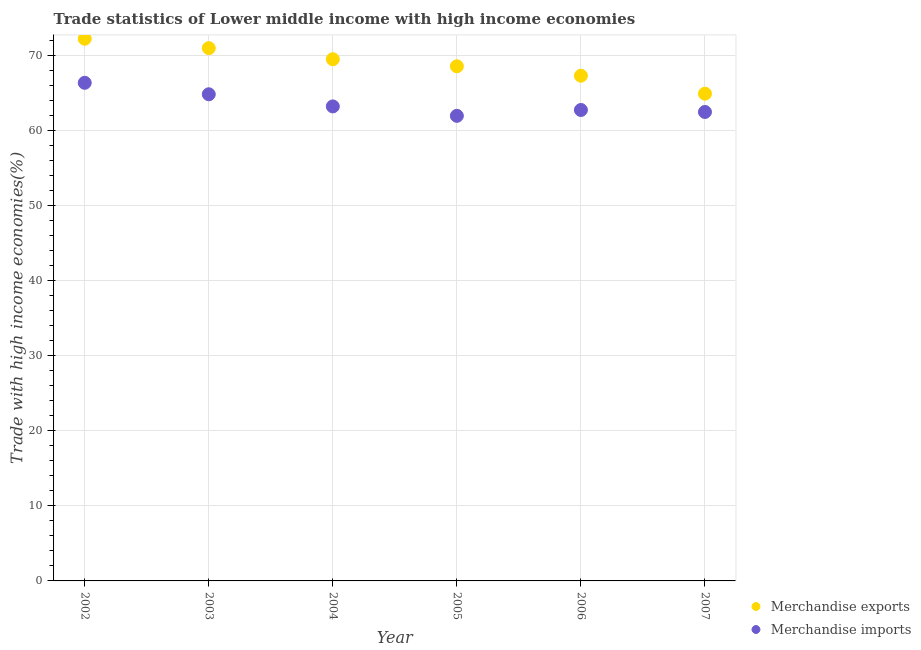Is the number of dotlines equal to the number of legend labels?
Offer a very short reply. Yes. What is the merchandise exports in 2005?
Ensure brevity in your answer.  68.62. Across all years, what is the maximum merchandise imports?
Make the answer very short. 66.42. Across all years, what is the minimum merchandise imports?
Keep it short and to the point. 62.02. What is the total merchandise imports in the graph?
Provide a succinct answer. 381.92. What is the difference between the merchandise exports in 2002 and that in 2003?
Your answer should be compact. 1.26. What is the difference between the merchandise exports in 2007 and the merchandise imports in 2006?
Provide a short and direct response. 2.17. What is the average merchandise exports per year?
Your answer should be compact. 68.98. In the year 2006, what is the difference between the merchandise imports and merchandise exports?
Offer a very short reply. -4.57. In how many years, is the merchandise imports greater than 30 %?
Give a very brief answer. 6. What is the ratio of the merchandise imports in 2004 to that in 2007?
Your answer should be very brief. 1.01. What is the difference between the highest and the second highest merchandise imports?
Your answer should be compact. 1.53. What is the difference between the highest and the lowest merchandise imports?
Offer a terse response. 4.4. Is the merchandise imports strictly greater than the merchandise exports over the years?
Keep it short and to the point. No. How many years are there in the graph?
Your answer should be compact. 6. What is the title of the graph?
Provide a short and direct response. Trade statistics of Lower middle income with high income economies. Does "Not attending school" appear as one of the legend labels in the graph?
Keep it short and to the point. No. What is the label or title of the X-axis?
Offer a terse response. Year. What is the label or title of the Y-axis?
Provide a succinct answer. Trade with high income economies(%). What is the Trade with high income economies(%) in Merchandise exports in 2002?
Provide a short and direct response. 72.3. What is the Trade with high income economies(%) of Merchandise imports in 2002?
Your answer should be very brief. 66.42. What is the Trade with high income economies(%) in Merchandise exports in 2003?
Provide a short and direct response. 71.04. What is the Trade with high income economies(%) in Merchandise imports in 2003?
Offer a very short reply. 64.89. What is the Trade with high income economies(%) in Merchandise exports in 2004?
Offer a very short reply. 69.56. What is the Trade with high income economies(%) of Merchandise imports in 2004?
Your answer should be compact. 63.27. What is the Trade with high income economies(%) of Merchandise exports in 2005?
Provide a succinct answer. 68.62. What is the Trade with high income economies(%) in Merchandise imports in 2005?
Your answer should be very brief. 62.02. What is the Trade with high income economies(%) of Merchandise exports in 2006?
Provide a short and direct response. 67.37. What is the Trade with high income economies(%) in Merchandise imports in 2006?
Your answer should be compact. 62.8. What is the Trade with high income economies(%) of Merchandise exports in 2007?
Provide a short and direct response. 64.97. What is the Trade with high income economies(%) of Merchandise imports in 2007?
Provide a succinct answer. 62.53. Across all years, what is the maximum Trade with high income economies(%) of Merchandise exports?
Make the answer very short. 72.3. Across all years, what is the maximum Trade with high income economies(%) of Merchandise imports?
Keep it short and to the point. 66.42. Across all years, what is the minimum Trade with high income economies(%) in Merchandise exports?
Your response must be concise. 64.97. Across all years, what is the minimum Trade with high income economies(%) of Merchandise imports?
Provide a succinct answer. 62.02. What is the total Trade with high income economies(%) of Merchandise exports in the graph?
Provide a succinct answer. 413.86. What is the total Trade with high income economies(%) of Merchandise imports in the graph?
Your answer should be compact. 381.92. What is the difference between the Trade with high income economies(%) in Merchandise exports in 2002 and that in 2003?
Ensure brevity in your answer.  1.26. What is the difference between the Trade with high income economies(%) of Merchandise imports in 2002 and that in 2003?
Give a very brief answer. 1.53. What is the difference between the Trade with high income economies(%) of Merchandise exports in 2002 and that in 2004?
Provide a succinct answer. 2.73. What is the difference between the Trade with high income economies(%) in Merchandise imports in 2002 and that in 2004?
Keep it short and to the point. 3.15. What is the difference between the Trade with high income economies(%) in Merchandise exports in 2002 and that in 2005?
Offer a very short reply. 3.67. What is the difference between the Trade with high income economies(%) in Merchandise imports in 2002 and that in 2005?
Your response must be concise. 4.4. What is the difference between the Trade with high income economies(%) of Merchandise exports in 2002 and that in 2006?
Offer a very short reply. 4.93. What is the difference between the Trade with high income economies(%) of Merchandise imports in 2002 and that in 2006?
Provide a short and direct response. 3.62. What is the difference between the Trade with high income economies(%) in Merchandise exports in 2002 and that in 2007?
Offer a very short reply. 7.33. What is the difference between the Trade with high income economies(%) in Merchandise imports in 2002 and that in 2007?
Give a very brief answer. 3.89. What is the difference between the Trade with high income economies(%) in Merchandise exports in 2003 and that in 2004?
Ensure brevity in your answer.  1.48. What is the difference between the Trade with high income economies(%) in Merchandise imports in 2003 and that in 2004?
Offer a terse response. 1.62. What is the difference between the Trade with high income economies(%) of Merchandise exports in 2003 and that in 2005?
Provide a short and direct response. 2.42. What is the difference between the Trade with high income economies(%) in Merchandise imports in 2003 and that in 2005?
Ensure brevity in your answer.  2.87. What is the difference between the Trade with high income economies(%) in Merchandise exports in 2003 and that in 2006?
Your answer should be compact. 3.68. What is the difference between the Trade with high income economies(%) of Merchandise imports in 2003 and that in 2006?
Your answer should be very brief. 2.09. What is the difference between the Trade with high income economies(%) of Merchandise exports in 2003 and that in 2007?
Offer a very short reply. 6.07. What is the difference between the Trade with high income economies(%) in Merchandise imports in 2003 and that in 2007?
Give a very brief answer. 2.36. What is the difference between the Trade with high income economies(%) of Merchandise exports in 2004 and that in 2005?
Provide a short and direct response. 0.94. What is the difference between the Trade with high income economies(%) of Merchandise imports in 2004 and that in 2005?
Give a very brief answer. 1.26. What is the difference between the Trade with high income economies(%) in Merchandise exports in 2004 and that in 2006?
Make the answer very short. 2.2. What is the difference between the Trade with high income economies(%) in Merchandise imports in 2004 and that in 2006?
Give a very brief answer. 0.48. What is the difference between the Trade with high income economies(%) of Merchandise exports in 2004 and that in 2007?
Provide a short and direct response. 4.59. What is the difference between the Trade with high income economies(%) in Merchandise imports in 2004 and that in 2007?
Offer a terse response. 0.74. What is the difference between the Trade with high income economies(%) in Merchandise exports in 2005 and that in 2006?
Ensure brevity in your answer.  1.26. What is the difference between the Trade with high income economies(%) in Merchandise imports in 2005 and that in 2006?
Ensure brevity in your answer.  -0.78. What is the difference between the Trade with high income economies(%) of Merchandise exports in 2005 and that in 2007?
Your answer should be compact. 3.65. What is the difference between the Trade with high income economies(%) of Merchandise imports in 2005 and that in 2007?
Your answer should be compact. -0.51. What is the difference between the Trade with high income economies(%) in Merchandise exports in 2006 and that in 2007?
Give a very brief answer. 2.4. What is the difference between the Trade with high income economies(%) of Merchandise imports in 2006 and that in 2007?
Keep it short and to the point. 0.27. What is the difference between the Trade with high income economies(%) in Merchandise exports in 2002 and the Trade with high income economies(%) in Merchandise imports in 2003?
Provide a short and direct response. 7.41. What is the difference between the Trade with high income economies(%) of Merchandise exports in 2002 and the Trade with high income economies(%) of Merchandise imports in 2004?
Offer a very short reply. 9.03. What is the difference between the Trade with high income economies(%) in Merchandise exports in 2002 and the Trade with high income economies(%) in Merchandise imports in 2005?
Make the answer very short. 10.28. What is the difference between the Trade with high income economies(%) in Merchandise exports in 2002 and the Trade with high income economies(%) in Merchandise imports in 2006?
Ensure brevity in your answer.  9.5. What is the difference between the Trade with high income economies(%) in Merchandise exports in 2002 and the Trade with high income economies(%) in Merchandise imports in 2007?
Provide a succinct answer. 9.77. What is the difference between the Trade with high income economies(%) in Merchandise exports in 2003 and the Trade with high income economies(%) in Merchandise imports in 2004?
Give a very brief answer. 7.77. What is the difference between the Trade with high income economies(%) of Merchandise exports in 2003 and the Trade with high income economies(%) of Merchandise imports in 2005?
Offer a terse response. 9.03. What is the difference between the Trade with high income economies(%) of Merchandise exports in 2003 and the Trade with high income economies(%) of Merchandise imports in 2006?
Your answer should be compact. 8.25. What is the difference between the Trade with high income economies(%) of Merchandise exports in 2003 and the Trade with high income economies(%) of Merchandise imports in 2007?
Offer a very short reply. 8.51. What is the difference between the Trade with high income economies(%) in Merchandise exports in 2004 and the Trade with high income economies(%) in Merchandise imports in 2005?
Provide a succinct answer. 7.55. What is the difference between the Trade with high income economies(%) in Merchandise exports in 2004 and the Trade with high income economies(%) in Merchandise imports in 2006?
Make the answer very short. 6.77. What is the difference between the Trade with high income economies(%) in Merchandise exports in 2004 and the Trade with high income economies(%) in Merchandise imports in 2007?
Make the answer very short. 7.03. What is the difference between the Trade with high income economies(%) in Merchandise exports in 2005 and the Trade with high income economies(%) in Merchandise imports in 2006?
Keep it short and to the point. 5.83. What is the difference between the Trade with high income economies(%) of Merchandise exports in 2005 and the Trade with high income economies(%) of Merchandise imports in 2007?
Provide a short and direct response. 6.09. What is the difference between the Trade with high income economies(%) of Merchandise exports in 2006 and the Trade with high income economies(%) of Merchandise imports in 2007?
Your answer should be very brief. 4.84. What is the average Trade with high income economies(%) in Merchandise exports per year?
Ensure brevity in your answer.  68.98. What is the average Trade with high income economies(%) in Merchandise imports per year?
Provide a short and direct response. 63.65. In the year 2002, what is the difference between the Trade with high income economies(%) of Merchandise exports and Trade with high income economies(%) of Merchandise imports?
Ensure brevity in your answer.  5.88. In the year 2003, what is the difference between the Trade with high income economies(%) in Merchandise exports and Trade with high income economies(%) in Merchandise imports?
Keep it short and to the point. 6.15. In the year 2004, what is the difference between the Trade with high income economies(%) in Merchandise exports and Trade with high income economies(%) in Merchandise imports?
Offer a very short reply. 6.29. In the year 2005, what is the difference between the Trade with high income economies(%) in Merchandise exports and Trade with high income economies(%) in Merchandise imports?
Your answer should be very brief. 6.61. In the year 2006, what is the difference between the Trade with high income economies(%) of Merchandise exports and Trade with high income economies(%) of Merchandise imports?
Make the answer very short. 4.57. In the year 2007, what is the difference between the Trade with high income economies(%) in Merchandise exports and Trade with high income economies(%) in Merchandise imports?
Your answer should be compact. 2.44. What is the ratio of the Trade with high income economies(%) of Merchandise exports in 2002 to that in 2003?
Make the answer very short. 1.02. What is the ratio of the Trade with high income economies(%) of Merchandise imports in 2002 to that in 2003?
Offer a very short reply. 1.02. What is the ratio of the Trade with high income economies(%) in Merchandise exports in 2002 to that in 2004?
Your answer should be compact. 1.04. What is the ratio of the Trade with high income economies(%) in Merchandise imports in 2002 to that in 2004?
Offer a terse response. 1.05. What is the ratio of the Trade with high income economies(%) in Merchandise exports in 2002 to that in 2005?
Provide a succinct answer. 1.05. What is the ratio of the Trade with high income economies(%) in Merchandise imports in 2002 to that in 2005?
Give a very brief answer. 1.07. What is the ratio of the Trade with high income economies(%) in Merchandise exports in 2002 to that in 2006?
Your answer should be compact. 1.07. What is the ratio of the Trade with high income economies(%) of Merchandise imports in 2002 to that in 2006?
Ensure brevity in your answer.  1.06. What is the ratio of the Trade with high income economies(%) of Merchandise exports in 2002 to that in 2007?
Provide a succinct answer. 1.11. What is the ratio of the Trade with high income economies(%) of Merchandise imports in 2002 to that in 2007?
Provide a short and direct response. 1.06. What is the ratio of the Trade with high income economies(%) in Merchandise exports in 2003 to that in 2004?
Give a very brief answer. 1.02. What is the ratio of the Trade with high income economies(%) of Merchandise imports in 2003 to that in 2004?
Provide a succinct answer. 1.03. What is the ratio of the Trade with high income economies(%) of Merchandise exports in 2003 to that in 2005?
Offer a very short reply. 1.04. What is the ratio of the Trade with high income economies(%) in Merchandise imports in 2003 to that in 2005?
Give a very brief answer. 1.05. What is the ratio of the Trade with high income economies(%) of Merchandise exports in 2003 to that in 2006?
Keep it short and to the point. 1.05. What is the ratio of the Trade with high income economies(%) in Merchandise imports in 2003 to that in 2006?
Offer a terse response. 1.03. What is the ratio of the Trade with high income economies(%) of Merchandise exports in 2003 to that in 2007?
Give a very brief answer. 1.09. What is the ratio of the Trade with high income economies(%) of Merchandise imports in 2003 to that in 2007?
Make the answer very short. 1.04. What is the ratio of the Trade with high income economies(%) of Merchandise exports in 2004 to that in 2005?
Give a very brief answer. 1.01. What is the ratio of the Trade with high income economies(%) in Merchandise imports in 2004 to that in 2005?
Offer a very short reply. 1.02. What is the ratio of the Trade with high income economies(%) of Merchandise exports in 2004 to that in 2006?
Make the answer very short. 1.03. What is the ratio of the Trade with high income economies(%) of Merchandise imports in 2004 to that in 2006?
Offer a terse response. 1.01. What is the ratio of the Trade with high income economies(%) of Merchandise exports in 2004 to that in 2007?
Give a very brief answer. 1.07. What is the ratio of the Trade with high income economies(%) of Merchandise imports in 2004 to that in 2007?
Provide a short and direct response. 1.01. What is the ratio of the Trade with high income economies(%) of Merchandise exports in 2005 to that in 2006?
Give a very brief answer. 1.02. What is the ratio of the Trade with high income economies(%) of Merchandise imports in 2005 to that in 2006?
Provide a succinct answer. 0.99. What is the ratio of the Trade with high income economies(%) in Merchandise exports in 2005 to that in 2007?
Offer a terse response. 1.06. What is the ratio of the Trade with high income economies(%) in Merchandise imports in 2005 to that in 2007?
Your answer should be very brief. 0.99. What is the ratio of the Trade with high income economies(%) of Merchandise exports in 2006 to that in 2007?
Offer a very short reply. 1.04. What is the ratio of the Trade with high income economies(%) of Merchandise imports in 2006 to that in 2007?
Your answer should be compact. 1. What is the difference between the highest and the second highest Trade with high income economies(%) in Merchandise exports?
Make the answer very short. 1.26. What is the difference between the highest and the second highest Trade with high income economies(%) of Merchandise imports?
Ensure brevity in your answer.  1.53. What is the difference between the highest and the lowest Trade with high income economies(%) of Merchandise exports?
Provide a short and direct response. 7.33. What is the difference between the highest and the lowest Trade with high income economies(%) in Merchandise imports?
Ensure brevity in your answer.  4.4. 